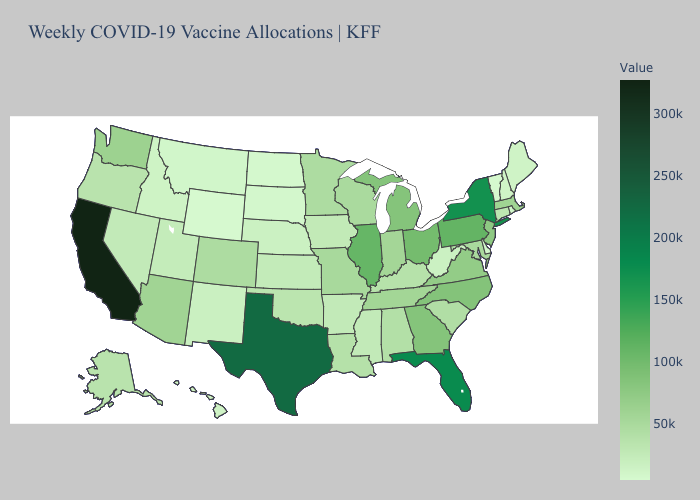Does Minnesota have the highest value in the USA?
Short answer required. No. Does Wyoming have the lowest value in the West?
Give a very brief answer. Yes. Which states have the highest value in the USA?
Answer briefly. California. Which states have the highest value in the USA?
Give a very brief answer. California. Among the states that border Ohio , which have the highest value?
Short answer required. Pennsylvania. 